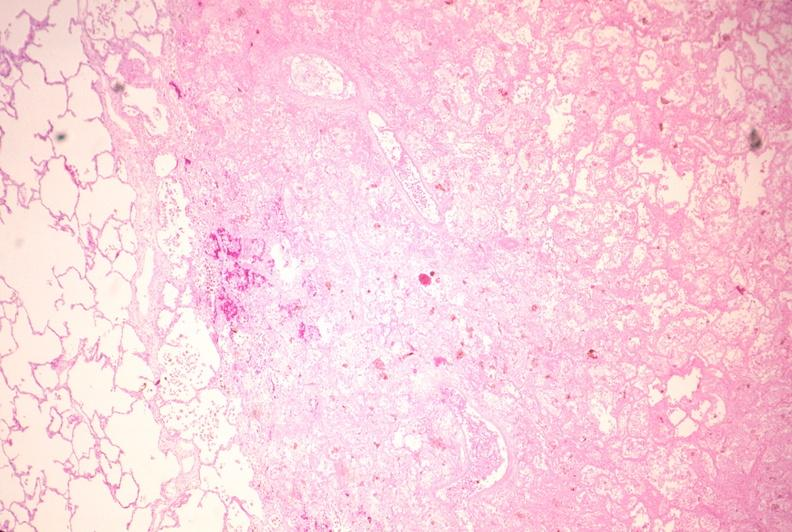does hypertension show lung, infarct, acute and organized?
Answer the question using a single word or phrase. No 